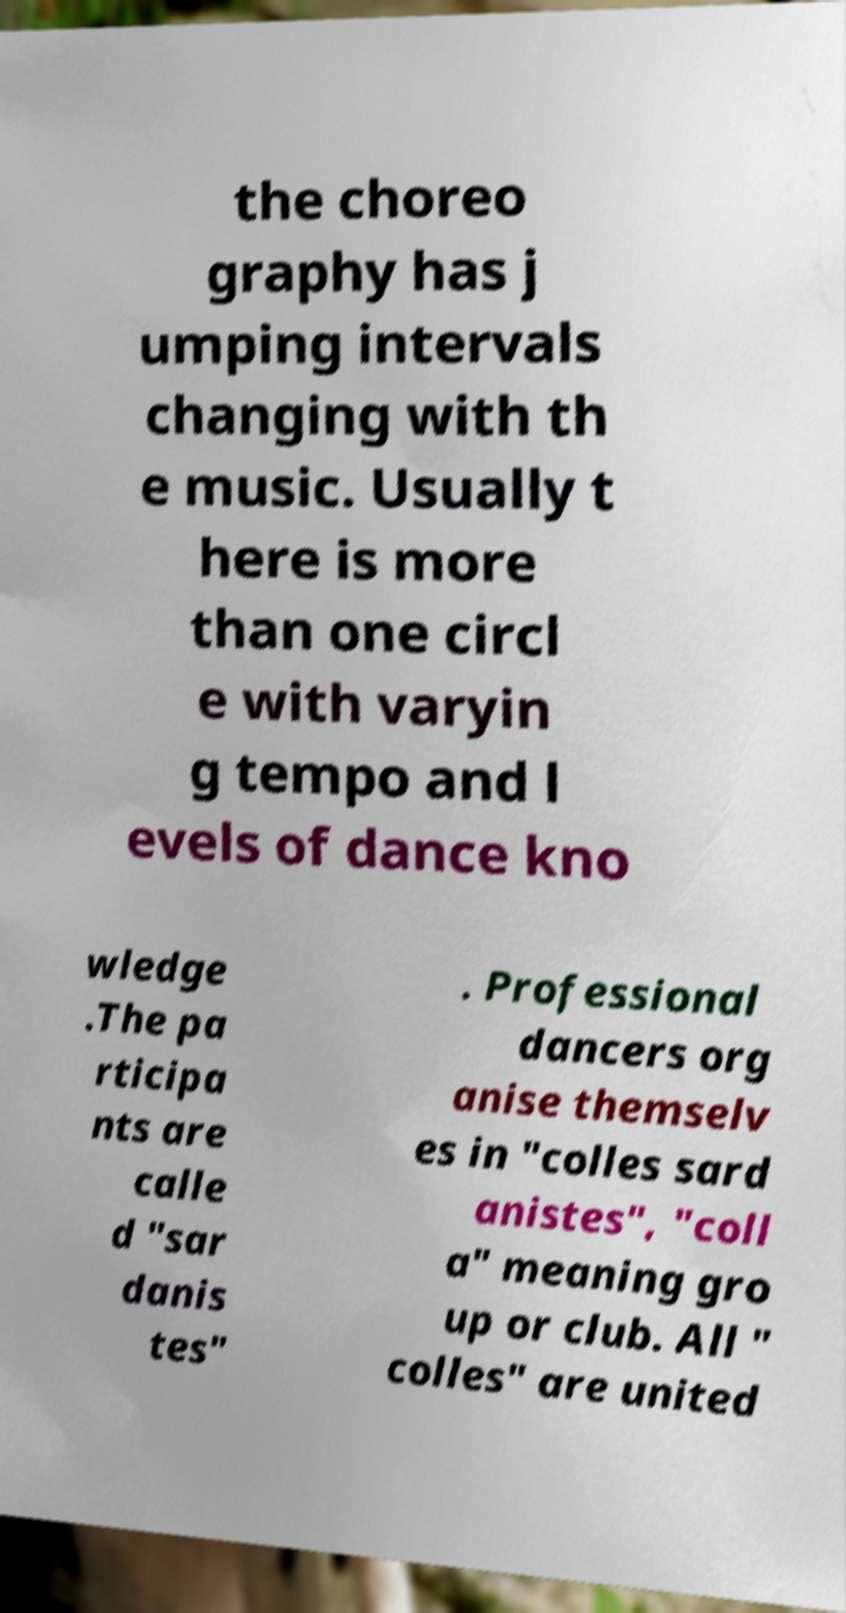Can you accurately transcribe the text from the provided image for me? the choreo graphy has j umping intervals changing with th e music. Usually t here is more than one circl e with varyin g tempo and l evels of dance kno wledge .The pa rticipa nts are calle d "sar danis tes" . Professional dancers org anise themselv es in "colles sard anistes", "coll a" meaning gro up or club. All " colles" are united 